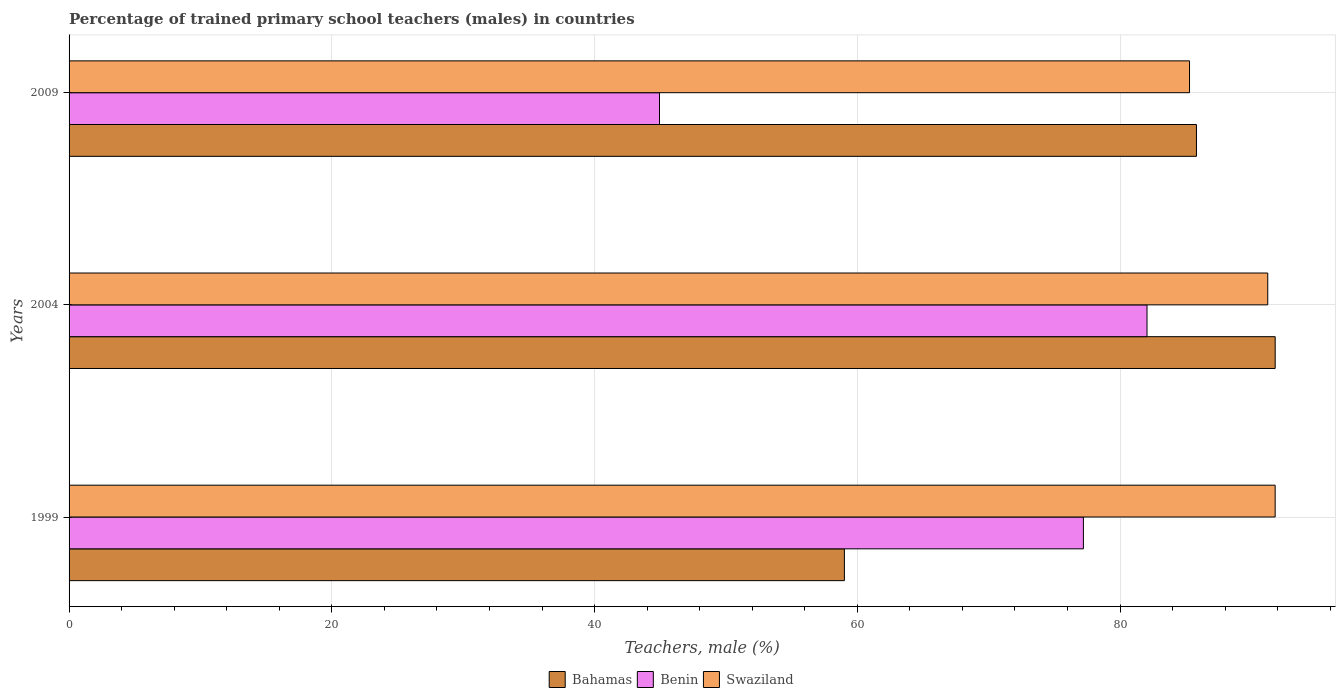Are the number of bars per tick equal to the number of legend labels?
Provide a succinct answer. Yes. Are the number of bars on each tick of the Y-axis equal?
Provide a short and direct response. Yes. What is the label of the 3rd group of bars from the top?
Ensure brevity in your answer.  1999. In how many cases, is the number of bars for a given year not equal to the number of legend labels?
Give a very brief answer. 0. What is the percentage of trained primary school teachers (males) in Bahamas in 1999?
Provide a succinct answer. 59.02. Across all years, what is the maximum percentage of trained primary school teachers (males) in Benin?
Your answer should be compact. 82.05. Across all years, what is the minimum percentage of trained primary school teachers (males) in Benin?
Offer a terse response. 44.94. In which year was the percentage of trained primary school teachers (males) in Bahamas minimum?
Give a very brief answer. 1999. What is the total percentage of trained primary school teachers (males) in Bahamas in the graph?
Your answer should be very brief. 236.64. What is the difference between the percentage of trained primary school teachers (males) in Swaziland in 1999 and that in 2009?
Your answer should be very brief. 6.52. What is the difference between the percentage of trained primary school teachers (males) in Swaziland in 2004 and the percentage of trained primary school teachers (males) in Bahamas in 2009?
Your answer should be compact. 5.43. What is the average percentage of trained primary school teachers (males) in Swaziland per year?
Your response must be concise. 89.44. In the year 2009, what is the difference between the percentage of trained primary school teachers (males) in Swaziland and percentage of trained primary school teachers (males) in Bahamas?
Provide a short and direct response. -0.53. What is the ratio of the percentage of trained primary school teachers (males) in Swaziland in 2004 to that in 2009?
Your response must be concise. 1.07. Is the percentage of trained primary school teachers (males) in Swaziland in 1999 less than that in 2004?
Provide a succinct answer. No. What is the difference between the highest and the second highest percentage of trained primary school teachers (males) in Benin?
Your response must be concise. 4.84. What is the difference between the highest and the lowest percentage of trained primary school teachers (males) in Benin?
Offer a very short reply. 37.11. In how many years, is the percentage of trained primary school teachers (males) in Swaziland greater than the average percentage of trained primary school teachers (males) in Swaziland taken over all years?
Ensure brevity in your answer.  2. What does the 1st bar from the top in 2004 represents?
Your answer should be very brief. Swaziland. What does the 1st bar from the bottom in 2004 represents?
Your answer should be compact. Bahamas. Is it the case that in every year, the sum of the percentage of trained primary school teachers (males) in Benin and percentage of trained primary school teachers (males) in Bahamas is greater than the percentage of trained primary school teachers (males) in Swaziland?
Give a very brief answer. Yes. Are all the bars in the graph horizontal?
Give a very brief answer. Yes. What is the difference between two consecutive major ticks on the X-axis?
Ensure brevity in your answer.  20. Does the graph contain any zero values?
Make the answer very short. No. Where does the legend appear in the graph?
Offer a terse response. Bottom center. How many legend labels are there?
Keep it short and to the point. 3. How are the legend labels stacked?
Give a very brief answer. Horizontal. What is the title of the graph?
Your answer should be very brief. Percentage of trained primary school teachers (males) in countries. Does "Peru" appear as one of the legend labels in the graph?
Offer a terse response. No. What is the label or title of the X-axis?
Your answer should be compact. Teachers, male (%). What is the Teachers, male (%) in Bahamas in 1999?
Provide a short and direct response. 59.02. What is the Teachers, male (%) of Benin in 1999?
Your answer should be compact. 77.21. What is the Teachers, male (%) in Swaziland in 1999?
Provide a short and direct response. 91.81. What is the Teachers, male (%) of Bahamas in 2004?
Ensure brevity in your answer.  91.81. What is the Teachers, male (%) in Benin in 2004?
Make the answer very short. 82.05. What is the Teachers, male (%) of Swaziland in 2004?
Offer a very short reply. 91.24. What is the Teachers, male (%) of Bahamas in 2009?
Your response must be concise. 85.82. What is the Teachers, male (%) of Benin in 2009?
Your answer should be compact. 44.94. What is the Teachers, male (%) of Swaziland in 2009?
Offer a very short reply. 85.29. Across all years, what is the maximum Teachers, male (%) in Bahamas?
Your response must be concise. 91.81. Across all years, what is the maximum Teachers, male (%) in Benin?
Your answer should be compact. 82.05. Across all years, what is the maximum Teachers, male (%) in Swaziland?
Provide a succinct answer. 91.81. Across all years, what is the minimum Teachers, male (%) of Bahamas?
Your answer should be very brief. 59.02. Across all years, what is the minimum Teachers, male (%) in Benin?
Your response must be concise. 44.94. Across all years, what is the minimum Teachers, male (%) in Swaziland?
Provide a succinct answer. 85.29. What is the total Teachers, male (%) of Bahamas in the graph?
Offer a terse response. 236.64. What is the total Teachers, male (%) in Benin in the graph?
Offer a very short reply. 204.2. What is the total Teachers, male (%) of Swaziland in the graph?
Offer a terse response. 268.33. What is the difference between the Teachers, male (%) in Bahamas in 1999 and that in 2004?
Offer a terse response. -32.79. What is the difference between the Teachers, male (%) of Benin in 1999 and that in 2004?
Offer a terse response. -4.84. What is the difference between the Teachers, male (%) of Swaziland in 1999 and that in 2004?
Keep it short and to the point. 0.56. What is the difference between the Teachers, male (%) of Bahamas in 1999 and that in 2009?
Ensure brevity in your answer.  -26.8. What is the difference between the Teachers, male (%) in Benin in 1999 and that in 2009?
Provide a short and direct response. 32.27. What is the difference between the Teachers, male (%) in Swaziland in 1999 and that in 2009?
Provide a succinct answer. 6.52. What is the difference between the Teachers, male (%) in Bahamas in 2004 and that in 2009?
Make the answer very short. 5.99. What is the difference between the Teachers, male (%) of Benin in 2004 and that in 2009?
Your answer should be very brief. 37.11. What is the difference between the Teachers, male (%) of Swaziland in 2004 and that in 2009?
Offer a terse response. 5.96. What is the difference between the Teachers, male (%) in Bahamas in 1999 and the Teachers, male (%) in Benin in 2004?
Ensure brevity in your answer.  -23.04. What is the difference between the Teachers, male (%) of Bahamas in 1999 and the Teachers, male (%) of Swaziland in 2004?
Provide a succinct answer. -32.23. What is the difference between the Teachers, male (%) in Benin in 1999 and the Teachers, male (%) in Swaziland in 2004?
Keep it short and to the point. -14.03. What is the difference between the Teachers, male (%) in Bahamas in 1999 and the Teachers, male (%) in Benin in 2009?
Provide a succinct answer. 14.07. What is the difference between the Teachers, male (%) in Bahamas in 1999 and the Teachers, male (%) in Swaziland in 2009?
Ensure brevity in your answer.  -26.27. What is the difference between the Teachers, male (%) in Benin in 1999 and the Teachers, male (%) in Swaziland in 2009?
Provide a short and direct response. -8.08. What is the difference between the Teachers, male (%) of Bahamas in 2004 and the Teachers, male (%) of Benin in 2009?
Make the answer very short. 46.87. What is the difference between the Teachers, male (%) in Bahamas in 2004 and the Teachers, male (%) in Swaziland in 2009?
Make the answer very short. 6.52. What is the difference between the Teachers, male (%) of Benin in 2004 and the Teachers, male (%) of Swaziland in 2009?
Provide a short and direct response. -3.23. What is the average Teachers, male (%) in Bahamas per year?
Provide a short and direct response. 78.88. What is the average Teachers, male (%) in Benin per year?
Keep it short and to the point. 68.07. What is the average Teachers, male (%) of Swaziland per year?
Your answer should be very brief. 89.44. In the year 1999, what is the difference between the Teachers, male (%) of Bahamas and Teachers, male (%) of Benin?
Your response must be concise. -18.19. In the year 1999, what is the difference between the Teachers, male (%) in Bahamas and Teachers, male (%) in Swaziland?
Make the answer very short. -32.79. In the year 1999, what is the difference between the Teachers, male (%) in Benin and Teachers, male (%) in Swaziland?
Keep it short and to the point. -14.6. In the year 2004, what is the difference between the Teachers, male (%) of Bahamas and Teachers, male (%) of Benin?
Offer a very short reply. 9.76. In the year 2004, what is the difference between the Teachers, male (%) in Bahamas and Teachers, male (%) in Swaziland?
Your answer should be compact. 0.57. In the year 2004, what is the difference between the Teachers, male (%) in Benin and Teachers, male (%) in Swaziland?
Ensure brevity in your answer.  -9.19. In the year 2009, what is the difference between the Teachers, male (%) of Bahamas and Teachers, male (%) of Benin?
Offer a terse response. 40.87. In the year 2009, what is the difference between the Teachers, male (%) of Bahamas and Teachers, male (%) of Swaziland?
Offer a terse response. 0.53. In the year 2009, what is the difference between the Teachers, male (%) in Benin and Teachers, male (%) in Swaziland?
Keep it short and to the point. -40.34. What is the ratio of the Teachers, male (%) of Bahamas in 1999 to that in 2004?
Keep it short and to the point. 0.64. What is the ratio of the Teachers, male (%) in Benin in 1999 to that in 2004?
Ensure brevity in your answer.  0.94. What is the ratio of the Teachers, male (%) in Swaziland in 1999 to that in 2004?
Make the answer very short. 1.01. What is the ratio of the Teachers, male (%) of Bahamas in 1999 to that in 2009?
Make the answer very short. 0.69. What is the ratio of the Teachers, male (%) of Benin in 1999 to that in 2009?
Keep it short and to the point. 1.72. What is the ratio of the Teachers, male (%) of Swaziland in 1999 to that in 2009?
Provide a short and direct response. 1.08. What is the ratio of the Teachers, male (%) in Bahamas in 2004 to that in 2009?
Your answer should be compact. 1.07. What is the ratio of the Teachers, male (%) in Benin in 2004 to that in 2009?
Ensure brevity in your answer.  1.83. What is the ratio of the Teachers, male (%) of Swaziland in 2004 to that in 2009?
Give a very brief answer. 1.07. What is the difference between the highest and the second highest Teachers, male (%) in Bahamas?
Offer a very short reply. 5.99. What is the difference between the highest and the second highest Teachers, male (%) in Benin?
Offer a very short reply. 4.84. What is the difference between the highest and the second highest Teachers, male (%) of Swaziland?
Give a very brief answer. 0.56. What is the difference between the highest and the lowest Teachers, male (%) of Bahamas?
Give a very brief answer. 32.79. What is the difference between the highest and the lowest Teachers, male (%) of Benin?
Your answer should be very brief. 37.11. What is the difference between the highest and the lowest Teachers, male (%) in Swaziland?
Provide a succinct answer. 6.52. 